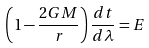Convert formula to latex. <formula><loc_0><loc_0><loc_500><loc_500>\left ( 1 - \frac { 2 G M } { r } \right ) \frac { d t } { d \lambda } = E</formula> 